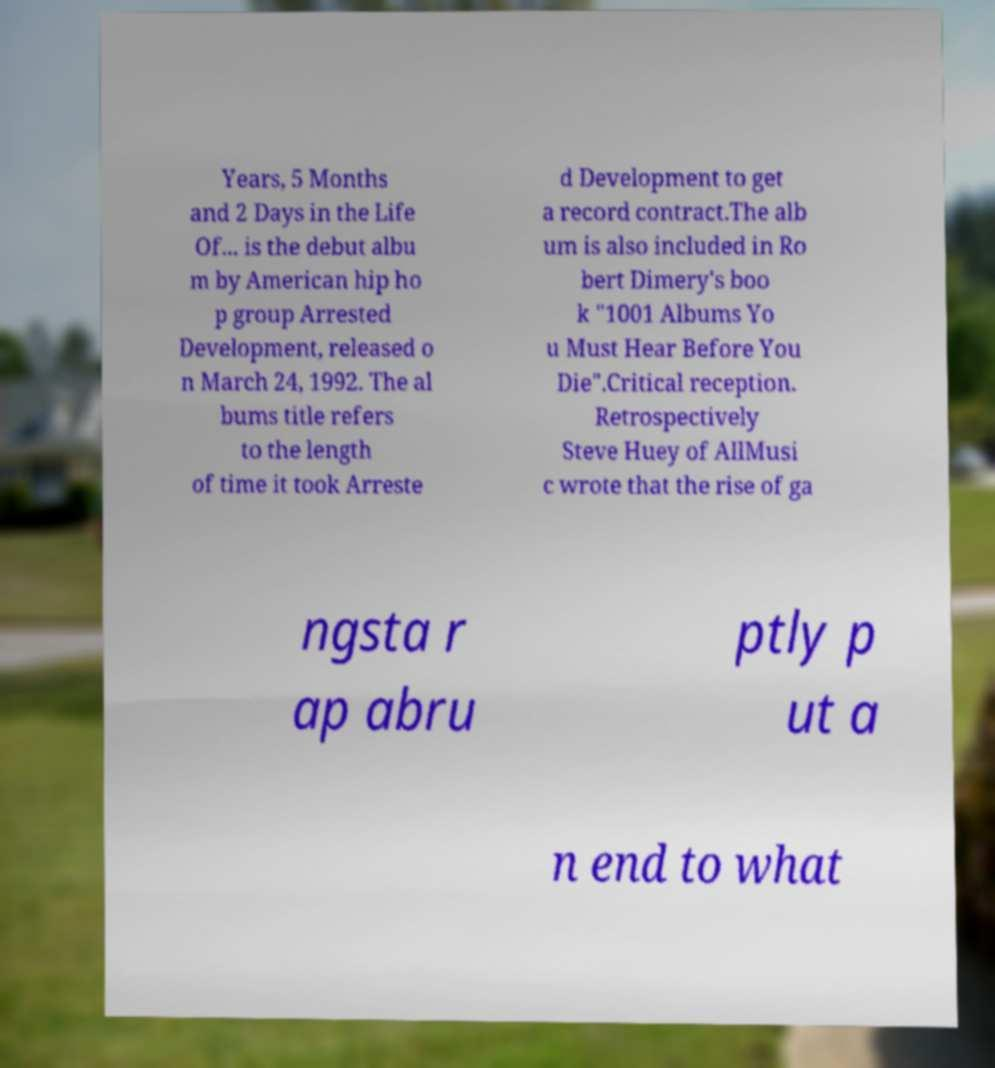Could you extract and type out the text from this image? Years, 5 Months and 2 Days in the Life Of... is the debut albu m by American hip ho p group Arrested Development, released o n March 24, 1992. The al bums title refers to the length of time it took Arreste d Development to get a record contract.The alb um is also included in Ro bert Dimery's boo k "1001 Albums Yo u Must Hear Before You Die".Critical reception. Retrospectively Steve Huey of AllMusi c wrote that the rise of ga ngsta r ap abru ptly p ut a n end to what 